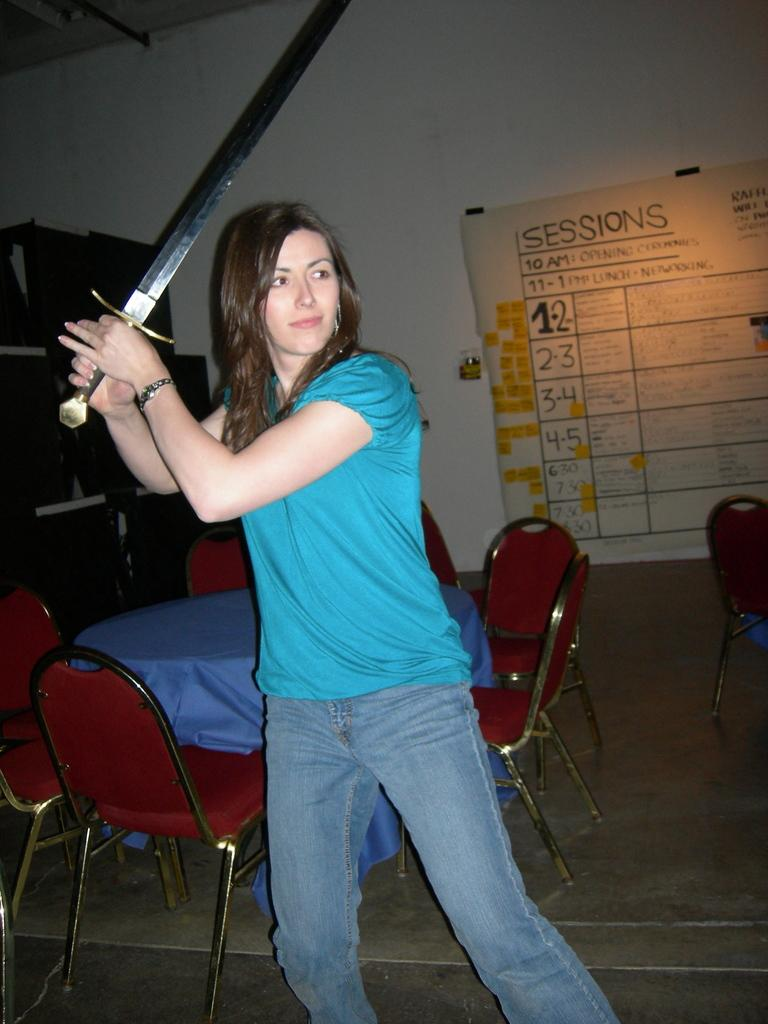Who is the main subject in the image? There is a woman in the image. What is the woman wearing? The woman is wearing a blue t-shirt. What is the woman holding in her hands? The woman is holding a sword in her hands. What can be seen in the background of the image? There are chairs and a table, as well as a chart on the wall, in the background of the image. How many chickens can be seen jumping through the hole in the image? There are no chickens or holes present in the image. 